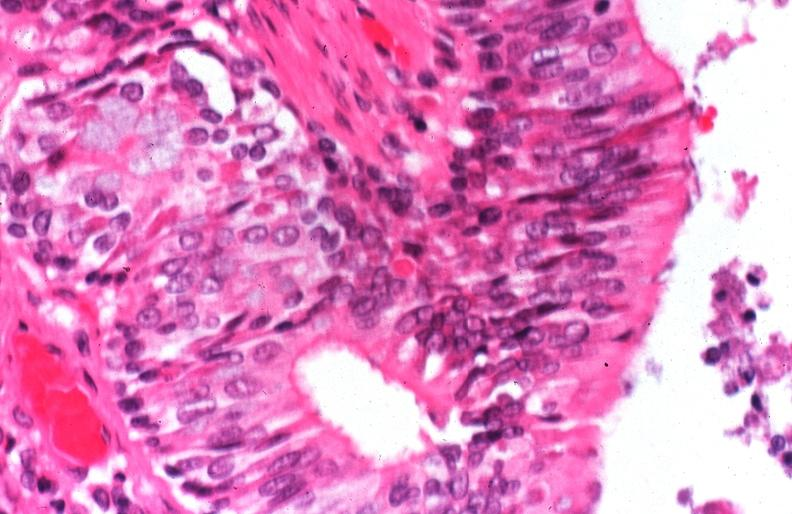s parathyroid present?
Answer the question using a single word or phrase. No 